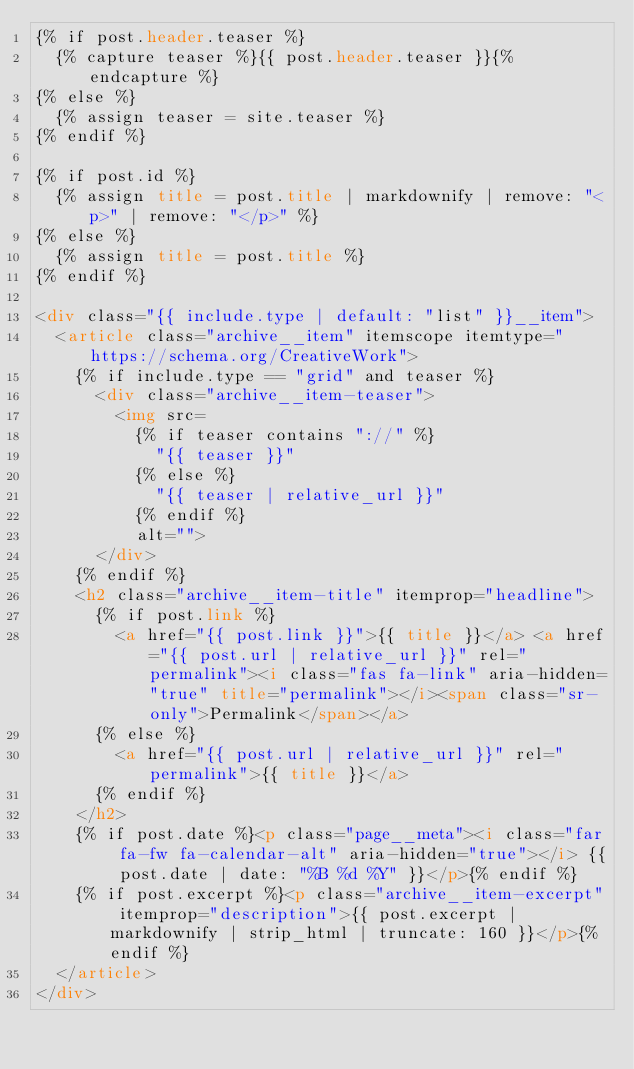Convert code to text. <code><loc_0><loc_0><loc_500><loc_500><_HTML_>{% if post.header.teaser %}
  {% capture teaser %}{{ post.header.teaser }}{% endcapture %}
{% else %}
  {% assign teaser = site.teaser %}
{% endif %}

{% if post.id %}
  {% assign title = post.title | markdownify | remove: "<p>" | remove: "</p>" %}
{% else %}
  {% assign title = post.title %}
{% endif %}

<div class="{{ include.type | default: "list" }}__item">
  <article class="archive__item" itemscope itemtype="https://schema.org/CreativeWork">
    {% if include.type == "grid" and teaser %}
      <div class="archive__item-teaser">
        <img src=
          {% if teaser contains "://" %}
            "{{ teaser }}"
          {% else %}
            "{{ teaser | relative_url }}"
          {% endif %}
          alt="">
      </div>
    {% endif %}
    <h2 class="archive__item-title" itemprop="headline">
      {% if post.link %}
        <a href="{{ post.link }}">{{ title }}</a> <a href="{{ post.url | relative_url }}" rel="permalink"><i class="fas fa-link" aria-hidden="true" title="permalink"></i><span class="sr-only">Permalink</span></a>
      {% else %}
        <a href="{{ post.url | relative_url }}" rel="permalink">{{ title }}</a>
      {% endif %}
    </h2>
    {% if post.date %}<p class="page__meta"><i class="far fa-fw fa-calendar-alt" aria-hidden="true"></i> {{ post.date | date: "%B %d %Y" }}</p>{% endif %}
    {% if post.excerpt %}<p class="archive__item-excerpt" itemprop="description">{{ post.excerpt | markdownify | strip_html | truncate: 160 }}</p>{% endif %}
  </article>
</div>
</code> 